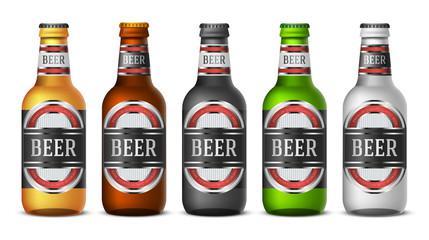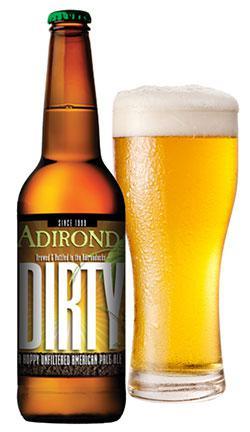The first image is the image on the left, the second image is the image on the right. For the images displayed, is the sentence "The bottles in the image on the left don't have lablels." factually correct? Answer yes or no. No. The first image is the image on the left, the second image is the image on the right. Analyze the images presented: Is the assertion "There is no more than 8 bottles." valid? Answer yes or no. Yes. 